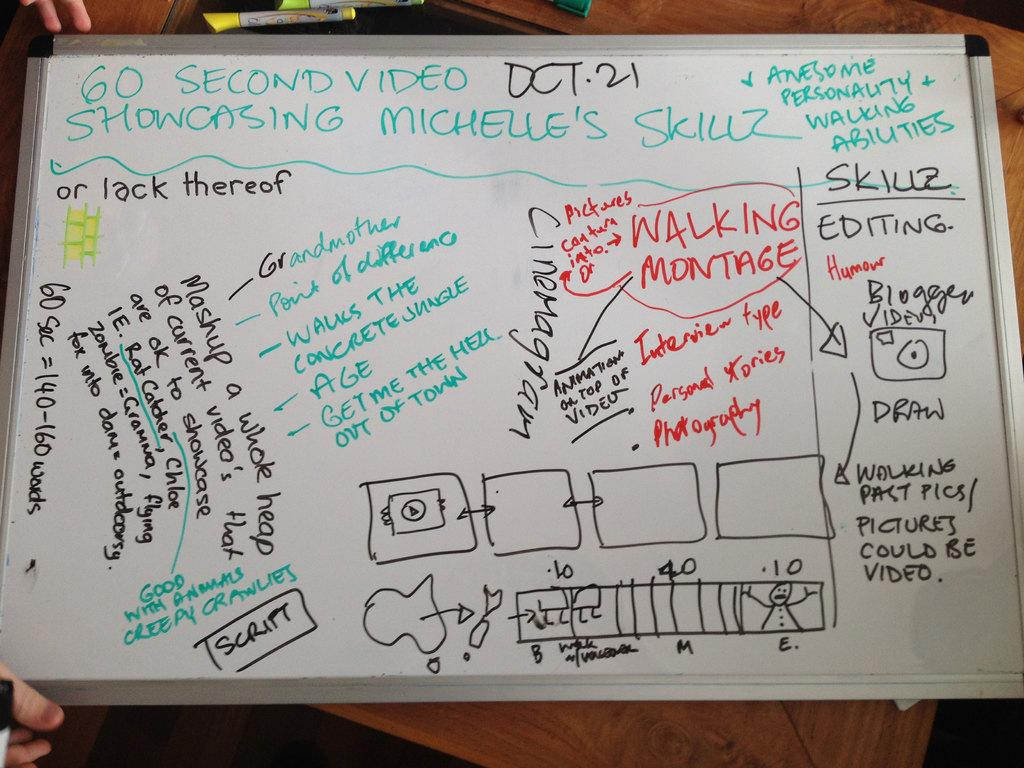What is the main object in the image? There is a whiteboard in the image. What can be seen on the whiteboard? The whiteboard has drawings on it and there is matter (text or information) on it. How many horses are depicted on the whiteboard in the image? There are no horses depicted on the whiteboard in the image. What type of good-bye message is written on the whiteboard in the image? There is no good-bye message present on the whiteboard in the image. 